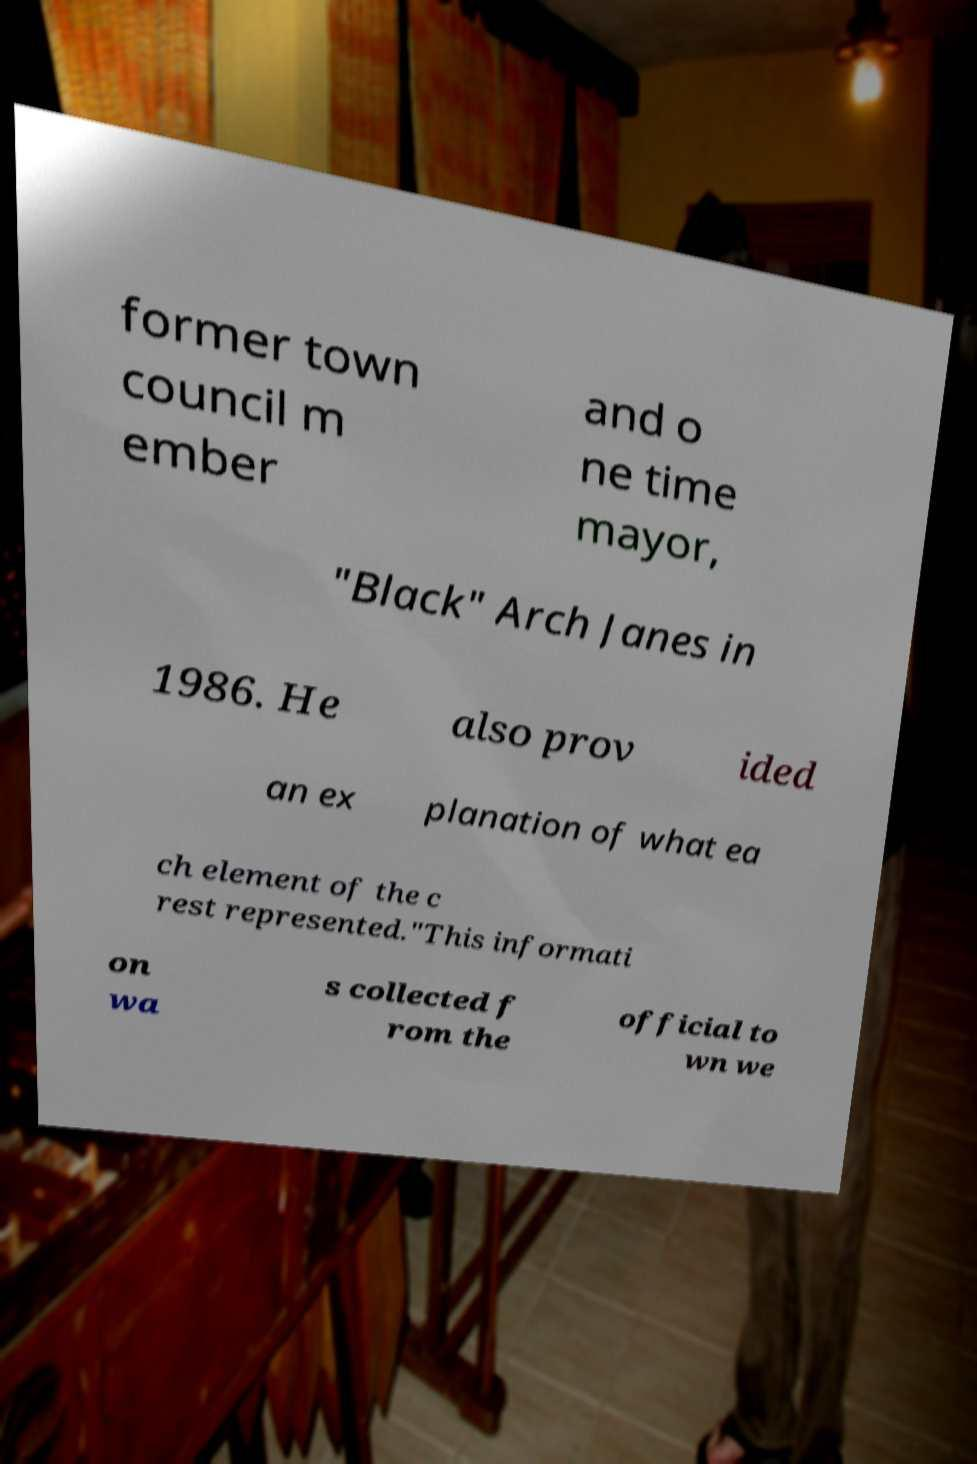For documentation purposes, I need the text within this image transcribed. Could you provide that? former town council m ember and o ne time mayor, "Black" Arch Janes in 1986. He also prov ided an ex planation of what ea ch element of the c rest represented."This informati on wa s collected f rom the official to wn we 